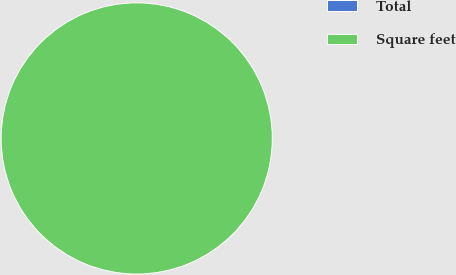<chart> <loc_0><loc_0><loc_500><loc_500><pie_chart><fcel>Total<fcel>Square feet<nl><fcel>0.0%<fcel>100.0%<nl></chart> 